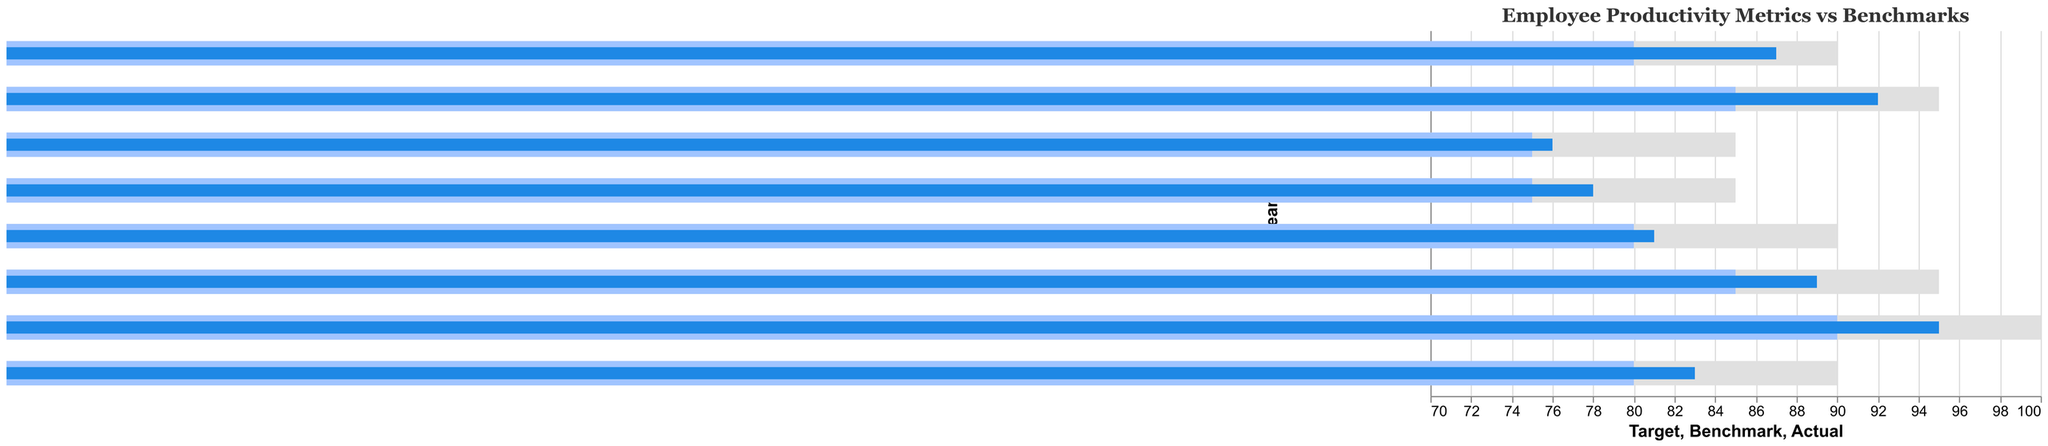What is the title of the chart? The title of the chart is displayed at the top center of the figure. It states the overall context of the plot.
Answer: Employee Productivity Metrics vs Benchmarks What colors represent the Actual, Benchmark, and Target metrics on the chart? The colors are used to distinguish different metrics: Actual is marked in dark blue, Benchmark is marked in light blue, and Target is marked in gray.
Answer: Dark blue for Actual, light blue for Benchmark, and gray for Target Which team has the highest Actual productivity? To determine this, we look at the segment with the highest value for the dark blue bar, representing the Actual productivity. Payroll has the highest bar.
Answer: Payroll Is there any team where the Actual productivity is below the Benchmark? We compare the Actual productivity (dark blue bar) to the Benchmark (light blue bar). The Actual productivity is below the Benchmark for none of the teams.
Answer: No How does the Actual productivity for Fixed Assets compare to its Target? For Fixed Assets, we look at the values of the dark blue bar for Actual and gray bar for Target. Actual (81) is below the Target (90).
Answer: Below What's the difference between the Actual and Benchmark productivity for Financial Reporting? The Actual productivity for Financial Reporting is 78, and the Benchmark is 75. The difference is found by subtracting the Benchmark from the Actual. 78 - 75 = 3.
Answer: 3 Which teams have an Actual productivity value greater than 85? We check each team's dark blue bar to see if its value is greater than 85. The teams are Accounts Receivable (92), Payroll (95), General Ledger (89), and Accounts Payable (87).
Answer: Accounts Receivable, Payroll, General Ledger, Accounts Payable 